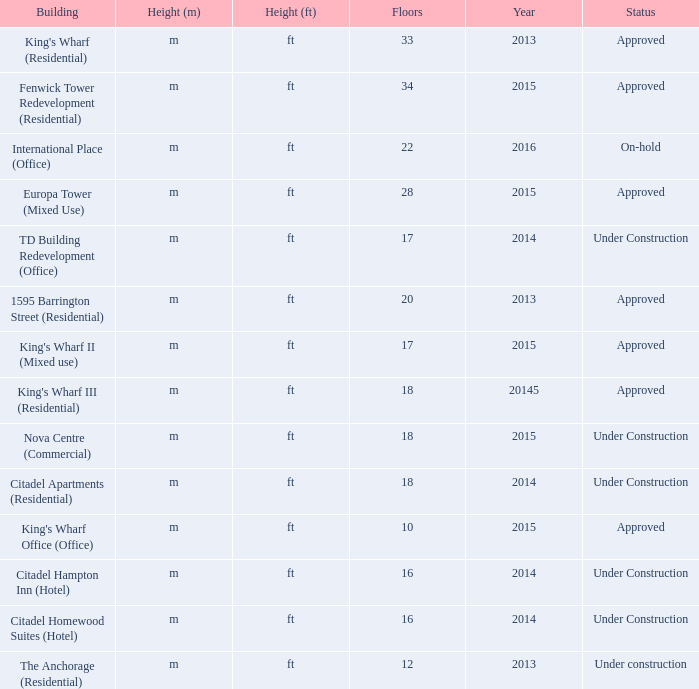What is the status of the building for 2014 with 33 floors? Approved. 